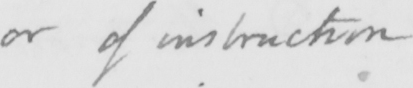Can you tell me what this handwritten text says? or of instruction 